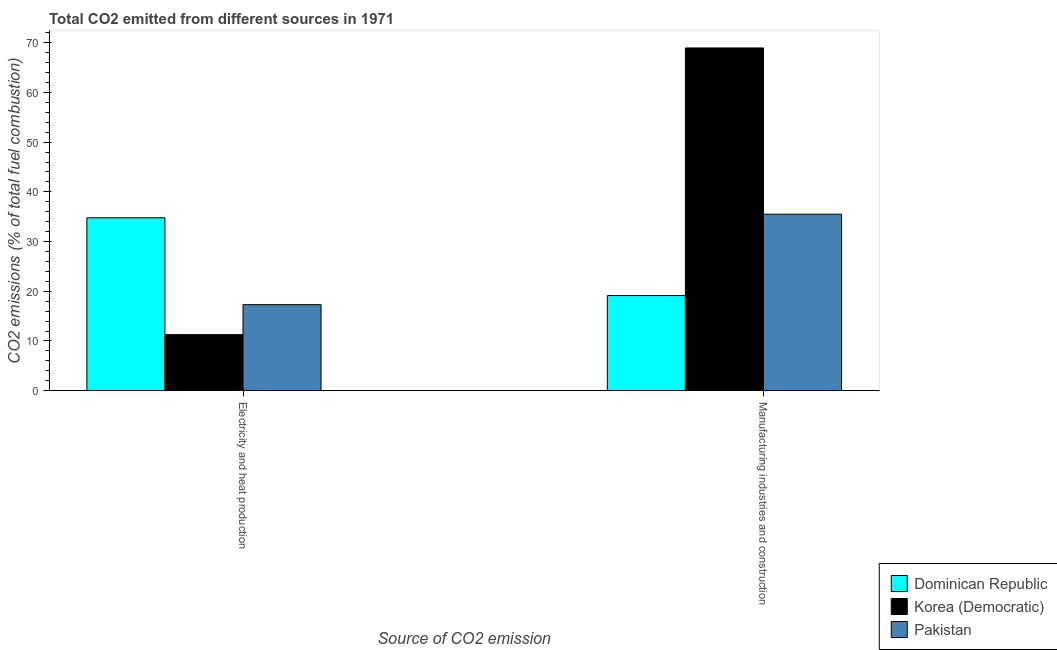Are the number of bars on each tick of the X-axis equal?
Your response must be concise. Yes. How many bars are there on the 1st tick from the right?
Make the answer very short. 3. What is the label of the 1st group of bars from the left?
Make the answer very short. Electricity and heat production. What is the co2 emissions due to electricity and heat production in Dominican Republic?
Keep it short and to the point. 34.78. Across all countries, what is the maximum co2 emissions due to electricity and heat production?
Make the answer very short. 34.78. Across all countries, what is the minimum co2 emissions due to electricity and heat production?
Give a very brief answer. 11.27. In which country was the co2 emissions due to electricity and heat production maximum?
Make the answer very short. Dominican Republic. In which country was the co2 emissions due to manufacturing industries minimum?
Your answer should be very brief. Dominican Republic. What is the total co2 emissions due to electricity and heat production in the graph?
Offer a terse response. 63.35. What is the difference between the co2 emissions due to electricity and heat production in Korea (Democratic) and that in Dominican Republic?
Your response must be concise. -23.51. What is the difference between the co2 emissions due to manufacturing industries in Korea (Democratic) and the co2 emissions due to electricity and heat production in Dominican Republic?
Give a very brief answer. 34.17. What is the average co2 emissions due to electricity and heat production per country?
Your answer should be very brief. 21.12. What is the difference between the co2 emissions due to electricity and heat production and co2 emissions due to manufacturing industries in Korea (Democratic)?
Keep it short and to the point. -57.68. In how many countries, is the co2 emissions due to manufacturing industries greater than 16 %?
Give a very brief answer. 3. What is the ratio of the co2 emissions due to electricity and heat production in Pakistan to that in Korea (Democratic)?
Provide a short and direct response. 1.53. Is the co2 emissions due to manufacturing industries in Korea (Democratic) less than that in Dominican Republic?
Make the answer very short. No. What does the 1st bar from the left in Manufacturing industries and construction represents?
Ensure brevity in your answer.  Dominican Republic. What does the 3rd bar from the right in Electricity and heat production represents?
Give a very brief answer. Dominican Republic. Are all the bars in the graph horizontal?
Offer a terse response. No. How many countries are there in the graph?
Keep it short and to the point. 3. What is the difference between two consecutive major ticks on the Y-axis?
Offer a very short reply. 10. Does the graph contain any zero values?
Ensure brevity in your answer.  No. How many legend labels are there?
Your response must be concise. 3. How are the legend labels stacked?
Ensure brevity in your answer.  Vertical. What is the title of the graph?
Make the answer very short. Total CO2 emitted from different sources in 1971. What is the label or title of the X-axis?
Your answer should be compact. Source of CO2 emission. What is the label or title of the Y-axis?
Ensure brevity in your answer.  CO2 emissions (% of total fuel combustion). What is the CO2 emissions (% of total fuel combustion) of Dominican Republic in Electricity and heat production?
Your answer should be compact. 34.78. What is the CO2 emissions (% of total fuel combustion) of Korea (Democratic) in Electricity and heat production?
Ensure brevity in your answer.  11.27. What is the CO2 emissions (% of total fuel combustion) in Pakistan in Electricity and heat production?
Offer a very short reply. 17.3. What is the CO2 emissions (% of total fuel combustion) in Dominican Republic in Manufacturing industries and construction?
Provide a succinct answer. 19.13. What is the CO2 emissions (% of total fuel combustion) of Korea (Democratic) in Manufacturing industries and construction?
Give a very brief answer. 68.95. What is the CO2 emissions (% of total fuel combustion) in Pakistan in Manufacturing industries and construction?
Your response must be concise. 35.5. Across all Source of CO2 emission, what is the maximum CO2 emissions (% of total fuel combustion) in Dominican Republic?
Provide a succinct answer. 34.78. Across all Source of CO2 emission, what is the maximum CO2 emissions (% of total fuel combustion) of Korea (Democratic)?
Provide a succinct answer. 68.95. Across all Source of CO2 emission, what is the maximum CO2 emissions (% of total fuel combustion) of Pakistan?
Keep it short and to the point. 35.5. Across all Source of CO2 emission, what is the minimum CO2 emissions (% of total fuel combustion) in Dominican Republic?
Offer a very short reply. 19.13. Across all Source of CO2 emission, what is the minimum CO2 emissions (% of total fuel combustion) in Korea (Democratic)?
Provide a short and direct response. 11.27. Across all Source of CO2 emission, what is the minimum CO2 emissions (% of total fuel combustion) of Pakistan?
Your answer should be compact. 17.3. What is the total CO2 emissions (% of total fuel combustion) of Dominican Republic in the graph?
Your answer should be very brief. 53.91. What is the total CO2 emissions (% of total fuel combustion) of Korea (Democratic) in the graph?
Keep it short and to the point. 80.23. What is the total CO2 emissions (% of total fuel combustion) of Pakistan in the graph?
Provide a succinct answer. 52.8. What is the difference between the CO2 emissions (% of total fuel combustion) of Dominican Republic in Electricity and heat production and that in Manufacturing industries and construction?
Make the answer very short. 15.65. What is the difference between the CO2 emissions (% of total fuel combustion) in Korea (Democratic) in Electricity and heat production and that in Manufacturing industries and construction?
Offer a terse response. -57.68. What is the difference between the CO2 emissions (% of total fuel combustion) of Pakistan in Electricity and heat production and that in Manufacturing industries and construction?
Your answer should be very brief. -18.2. What is the difference between the CO2 emissions (% of total fuel combustion) of Dominican Republic in Electricity and heat production and the CO2 emissions (% of total fuel combustion) of Korea (Democratic) in Manufacturing industries and construction?
Your response must be concise. -34.17. What is the difference between the CO2 emissions (% of total fuel combustion) of Dominican Republic in Electricity and heat production and the CO2 emissions (% of total fuel combustion) of Pakistan in Manufacturing industries and construction?
Ensure brevity in your answer.  -0.72. What is the difference between the CO2 emissions (% of total fuel combustion) of Korea (Democratic) in Electricity and heat production and the CO2 emissions (% of total fuel combustion) of Pakistan in Manufacturing industries and construction?
Your response must be concise. -24.23. What is the average CO2 emissions (% of total fuel combustion) of Dominican Republic per Source of CO2 emission?
Your response must be concise. 26.96. What is the average CO2 emissions (% of total fuel combustion) in Korea (Democratic) per Source of CO2 emission?
Offer a terse response. 40.11. What is the average CO2 emissions (% of total fuel combustion) in Pakistan per Source of CO2 emission?
Offer a very short reply. 26.4. What is the difference between the CO2 emissions (% of total fuel combustion) of Dominican Republic and CO2 emissions (% of total fuel combustion) of Korea (Democratic) in Electricity and heat production?
Make the answer very short. 23.51. What is the difference between the CO2 emissions (% of total fuel combustion) in Dominican Republic and CO2 emissions (% of total fuel combustion) in Pakistan in Electricity and heat production?
Ensure brevity in your answer.  17.48. What is the difference between the CO2 emissions (% of total fuel combustion) of Korea (Democratic) and CO2 emissions (% of total fuel combustion) of Pakistan in Electricity and heat production?
Your response must be concise. -6.03. What is the difference between the CO2 emissions (% of total fuel combustion) of Dominican Republic and CO2 emissions (% of total fuel combustion) of Korea (Democratic) in Manufacturing industries and construction?
Offer a very short reply. -49.82. What is the difference between the CO2 emissions (% of total fuel combustion) in Dominican Republic and CO2 emissions (% of total fuel combustion) in Pakistan in Manufacturing industries and construction?
Offer a terse response. -16.37. What is the difference between the CO2 emissions (% of total fuel combustion) in Korea (Democratic) and CO2 emissions (% of total fuel combustion) in Pakistan in Manufacturing industries and construction?
Provide a short and direct response. 33.45. What is the ratio of the CO2 emissions (% of total fuel combustion) in Dominican Republic in Electricity and heat production to that in Manufacturing industries and construction?
Provide a succinct answer. 1.82. What is the ratio of the CO2 emissions (% of total fuel combustion) of Korea (Democratic) in Electricity and heat production to that in Manufacturing industries and construction?
Ensure brevity in your answer.  0.16. What is the ratio of the CO2 emissions (% of total fuel combustion) of Pakistan in Electricity and heat production to that in Manufacturing industries and construction?
Your answer should be compact. 0.49. What is the difference between the highest and the second highest CO2 emissions (% of total fuel combustion) of Dominican Republic?
Your response must be concise. 15.65. What is the difference between the highest and the second highest CO2 emissions (% of total fuel combustion) of Korea (Democratic)?
Provide a short and direct response. 57.68. What is the difference between the highest and the second highest CO2 emissions (% of total fuel combustion) of Pakistan?
Your response must be concise. 18.2. What is the difference between the highest and the lowest CO2 emissions (% of total fuel combustion) of Dominican Republic?
Offer a terse response. 15.65. What is the difference between the highest and the lowest CO2 emissions (% of total fuel combustion) in Korea (Democratic)?
Provide a succinct answer. 57.68. What is the difference between the highest and the lowest CO2 emissions (% of total fuel combustion) of Pakistan?
Offer a very short reply. 18.2. 